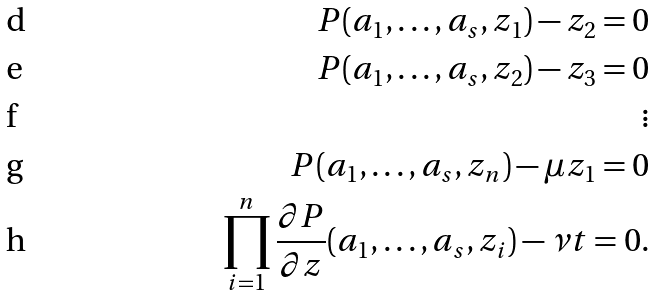<formula> <loc_0><loc_0><loc_500><loc_500>P ( a _ { 1 } , \dots , a _ { s } , z _ { 1 } ) - z _ { 2 } = 0 \\ P ( a _ { 1 } , \dots , a _ { s } , z _ { 2 } ) - z _ { 3 } = 0 \\ \vdots \\ P ( a _ { 1 } , \dots , a _ { s } , z _ { n } ) - \mu z _ { 1 } = 0 \\ \prod _ { i = 1 } ^ { n } \frac { \partial P } { \partial z } ( a _ { 1 } , \dots , a _ { s } , z _ { i } ) - \nu t = 0 .</formula> 